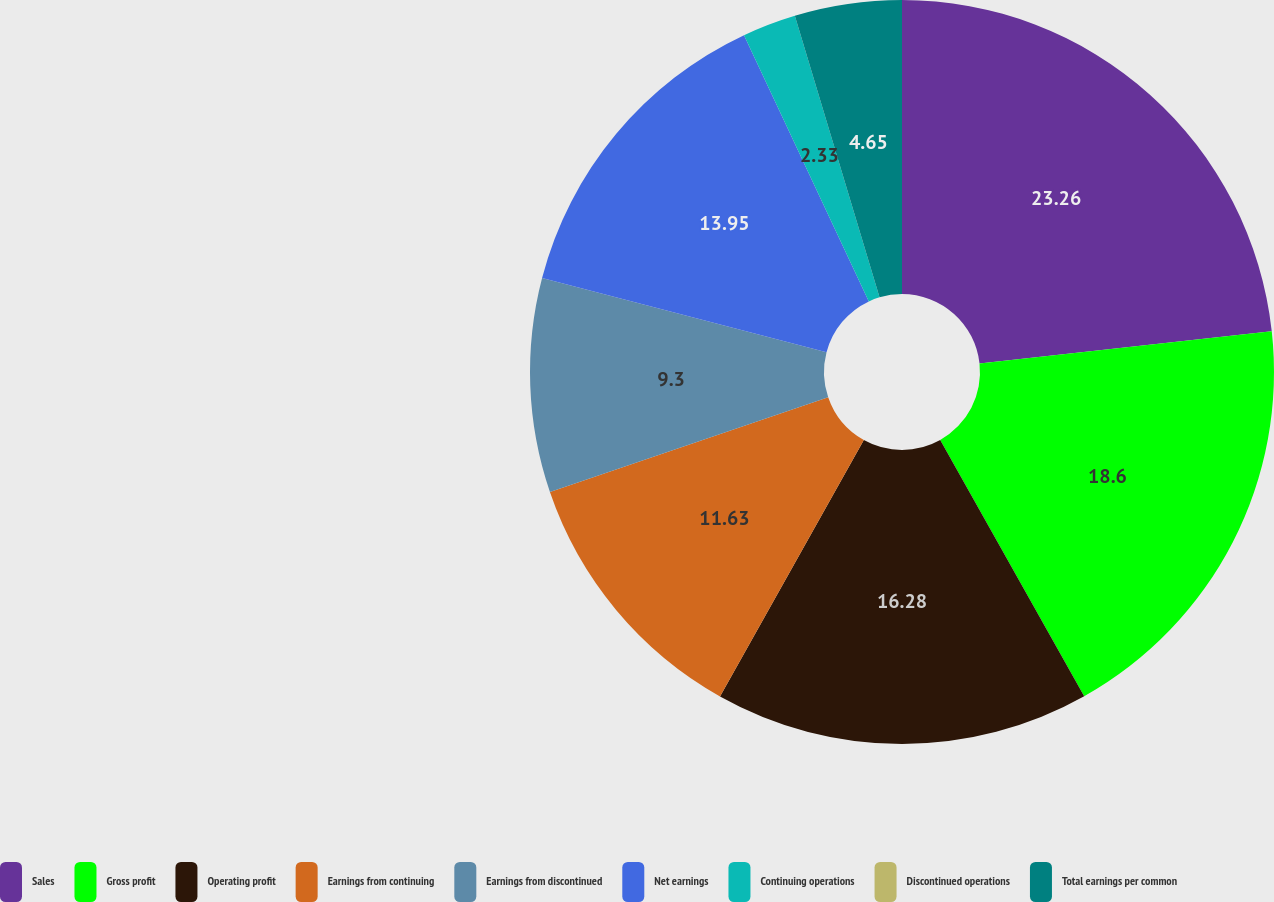Convert chart. <chart><loc_0><loc_0><loc_500><loc_500><pie_chart><fcel>Sales<fcel>Gross profit<fcel>Operating profit<fcel>Earnings from continuing<fcel>Earnings from discontinued<fcel>Net earnings<fcel>Continuing operations<fcel>Discontinued operations<fcel>Total earnings per common<nl><fcel>23.25%<fcel>18.6%<fcel>16.28%<fcel>11.63%<fcel>9.3%<fcel>13.95%<fcel>2.33%<fcel>0.0%<fcel>4.65%<nl></chart> 